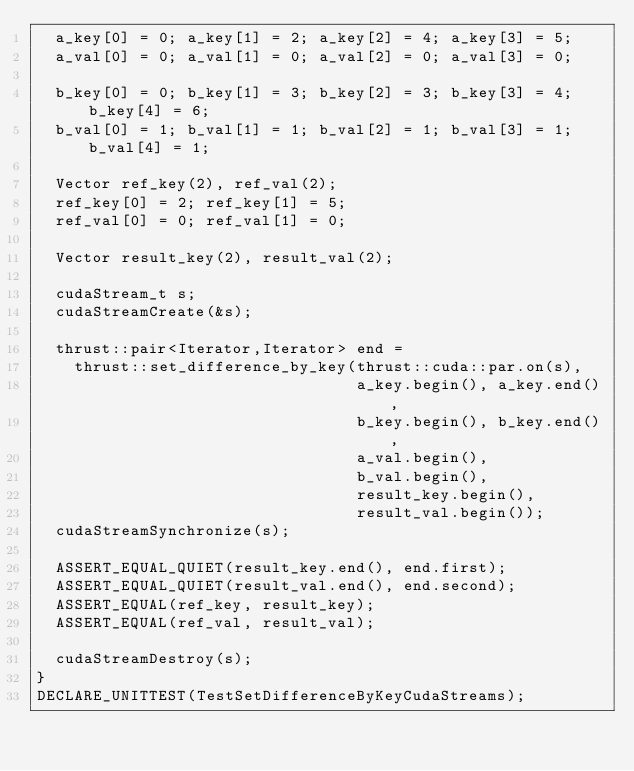Convert code to text. <code><loc_0><loc_0><loc_500><loc_500><_Cuda_>  a_key[0] = 0; a_key[1] = 2; a_key[2] = 4; a_key[3] = 5;
  a_val[0] = 0; a_val[1] = 0; a_val[2] = 0; a_val[3] = 0;

  b_key[0] = 0; b_key[1] = 3; b_key[2] = 3; b_key[3] = 4; b_key[4] = 6;
  b_val[0] = 1; b_val[1] = 1; b_val[2] = 1; b_val[3] = 1; b_val[4] = 1;

  Vector ref_key(2), ref_val(2);
  ref_key[0] = 2; ref_key[1] = 5;
  ref_val[0] = 0; ref_val[1] = 0;

  Vector result_key(2), result_val(2);

  cudaStream_t s;
  cudaStreamCreate(&s);

  thrust::pair<Iterator,Iterator> end =
    thrust::set_difference_by_key(thrust::cuda::par.on(s),
                                  a_key.begin(), a_key.end(),
                                  b_key.begin(), b_key.end(),
                                  a_val.begin(),
                                  b_val.begin(),
                                  result_key.begin(),
                                  result_val.begin());
  cudaStreamSynchronize(s);

  ASSERT_EQUAL_QUIET(result_key.end(), end.first);
  ASSERT_EQUAL_QUIET(result_val.end(), end.second);
  ASSERT_EQUAL(ref_key, result_key);
  ASSERT_EQUAL(ref_val, result_val);

  cudaStreamDestroy(s);
}
DECLARE_UNITTEST(TestSetDifferenceByKeyCudaStreams);

</code> 